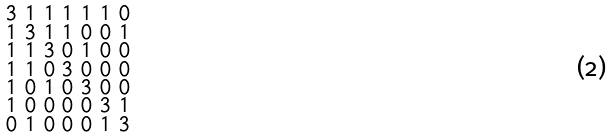Convert formula to latex. <formula><loc_0><loc_0><loc_500><loc_500>\begin{smallmatrix} 3 & 1 & 1 & 1 & 1 & 1 & 0 \\ 1 & 3 & 1 & 1 & 0 & 0 & 1 \\ 1 & 1 & 3 & 0 & 1 & 0 & 0 \\ 1 & 1 & 0 & 3 & 0 & 0 & 0 \\ 1 & 0 & 1 & 0 & 3 & 0 & 0 \\ 1 & 0 & 0 & 0 & 0 & 3 & 1 \\ 0 & 1 & 0 & 0 & 0 & 1 & 3 \end{smallmatrix}</formula> 